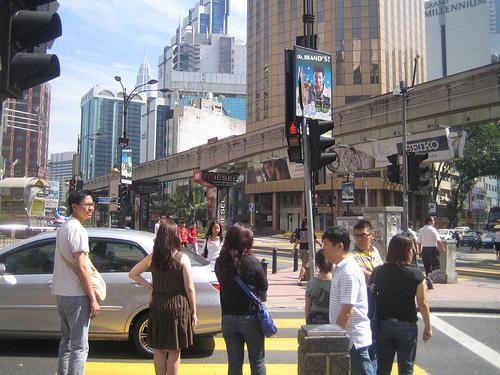How many people can you see?
Give a very brief answer. 5. How many sinks are there?
Give a very brief answer. 0. 